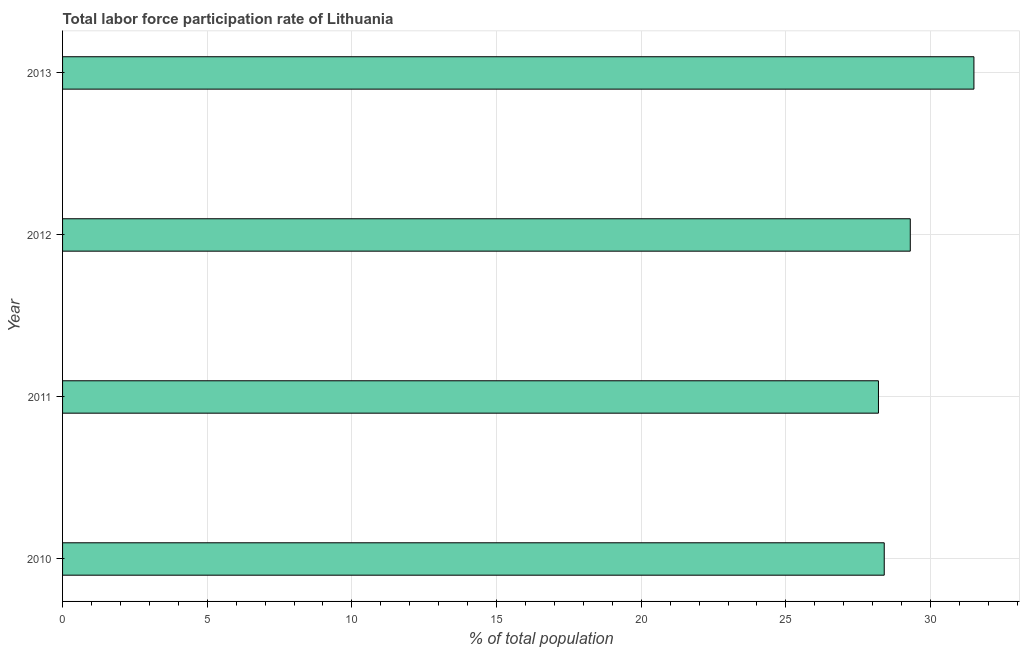Does the graph contain any zero values?
Your answer should be compact. No. What is the title of the graph?
Offer a very short reply. Total labor force participation rate of Lithuania. What is the label or title of the X-axis?
Your answer should be very brief. % of total population. What is the total labor force participation rate in 2011?
Give a very brief answer. 28.2. Across all years, what is the maximum total labor force participation rate?
Your answer should be compact. 31.5. Across all years, what is the minimum total labor force participation rate?
Give a very brief answer. 28.2. In which year was the total labor force participation rate minimum?
Provide a short and direct response. 2011. What is the sum of the total labor force participation rate?
Your response must be concise. 117.4. What is the average total labor force participation rate per year?
Provide a succinct answer. 29.35. What is the median total labor force participation rate?
Your answer should be compact. 28.85. Do a majority of the years between 2011 and 2012 (inclusive) have total labor force participation rate greater than 3 %?
Provide a short and direct response. Yes. Is the difference between the total labor force participation rate in 2010 and 2012 greater than the difference between any two years?
Make the answer very short. No. What is the difference between the highest and the second highest total labor force participation rate?
Your response must be concise. 2.2. Is the sum of the total labor force participation rate in 2010 and 2013 greater than the maximum total labor force participation rate across all years?
Make the answer very short. Yes. How many bars are there?
Keep it short and to the point. 4. Are the values on the major ticks of X-axis written in scientific E-notation?
Offer a terse response. No. What is the % of total population in 2010?
Provide a succinct answer. 28.4. What is the % of total population of 2011?
Give a very brief answer. 28.2. What is the % of total population of 2012?
Your response must be concise. 29.3. What is the % of total population in 2013?
Provide a succinct answer. 31.5. What is the difference between the % of total population in 2010 and 2013?
Your response must be concise. -3.1. What is the difference between the % of total population in 2011 and 2012?
Offer a terse response. -1.1. What is the ratio of the % of total population in 2010 to that in 2011?
Keep it short and to the point. 1.01. What is the ratio of the % of total population in 2010 to that in 2012?
Your response must be concise. 0.97. What is the ratio of the % of total population in 2010 to that in 2013?
Offer a terse response. 0.9. What is the ratio of the % of total population in 2011 to that in 2012?
Your answer should be compact. 0.96. What is the ratio of the % of total population in 2011 to that in 2013?
Offer a terse response. 0.9. What is the ratio of the % of total population in 2012 to that in 2013?
Provide a short and direct response. 0.93. 